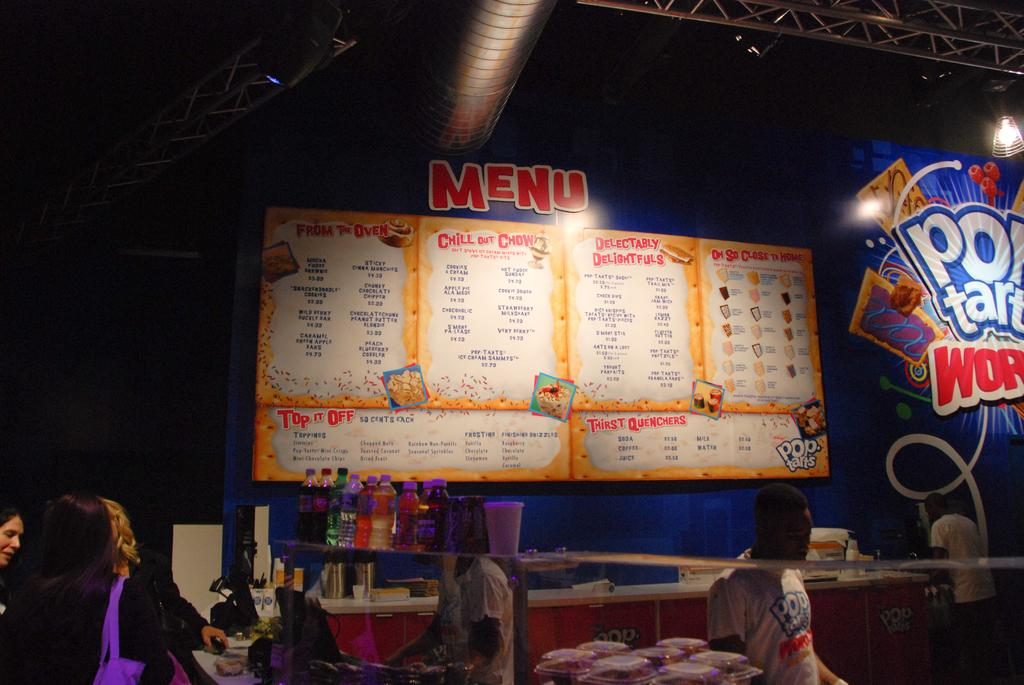What is the main subject of the image? The main subject of the image is a group of people standing. What objects can be seen in the image besides the people? There are bottles, other items, a board, focus lights, and a lighting truss in the image. What time is it in the image? The image does not provide any information about the time. Is there a swing present in the image? No, there is no swing present in the image. 